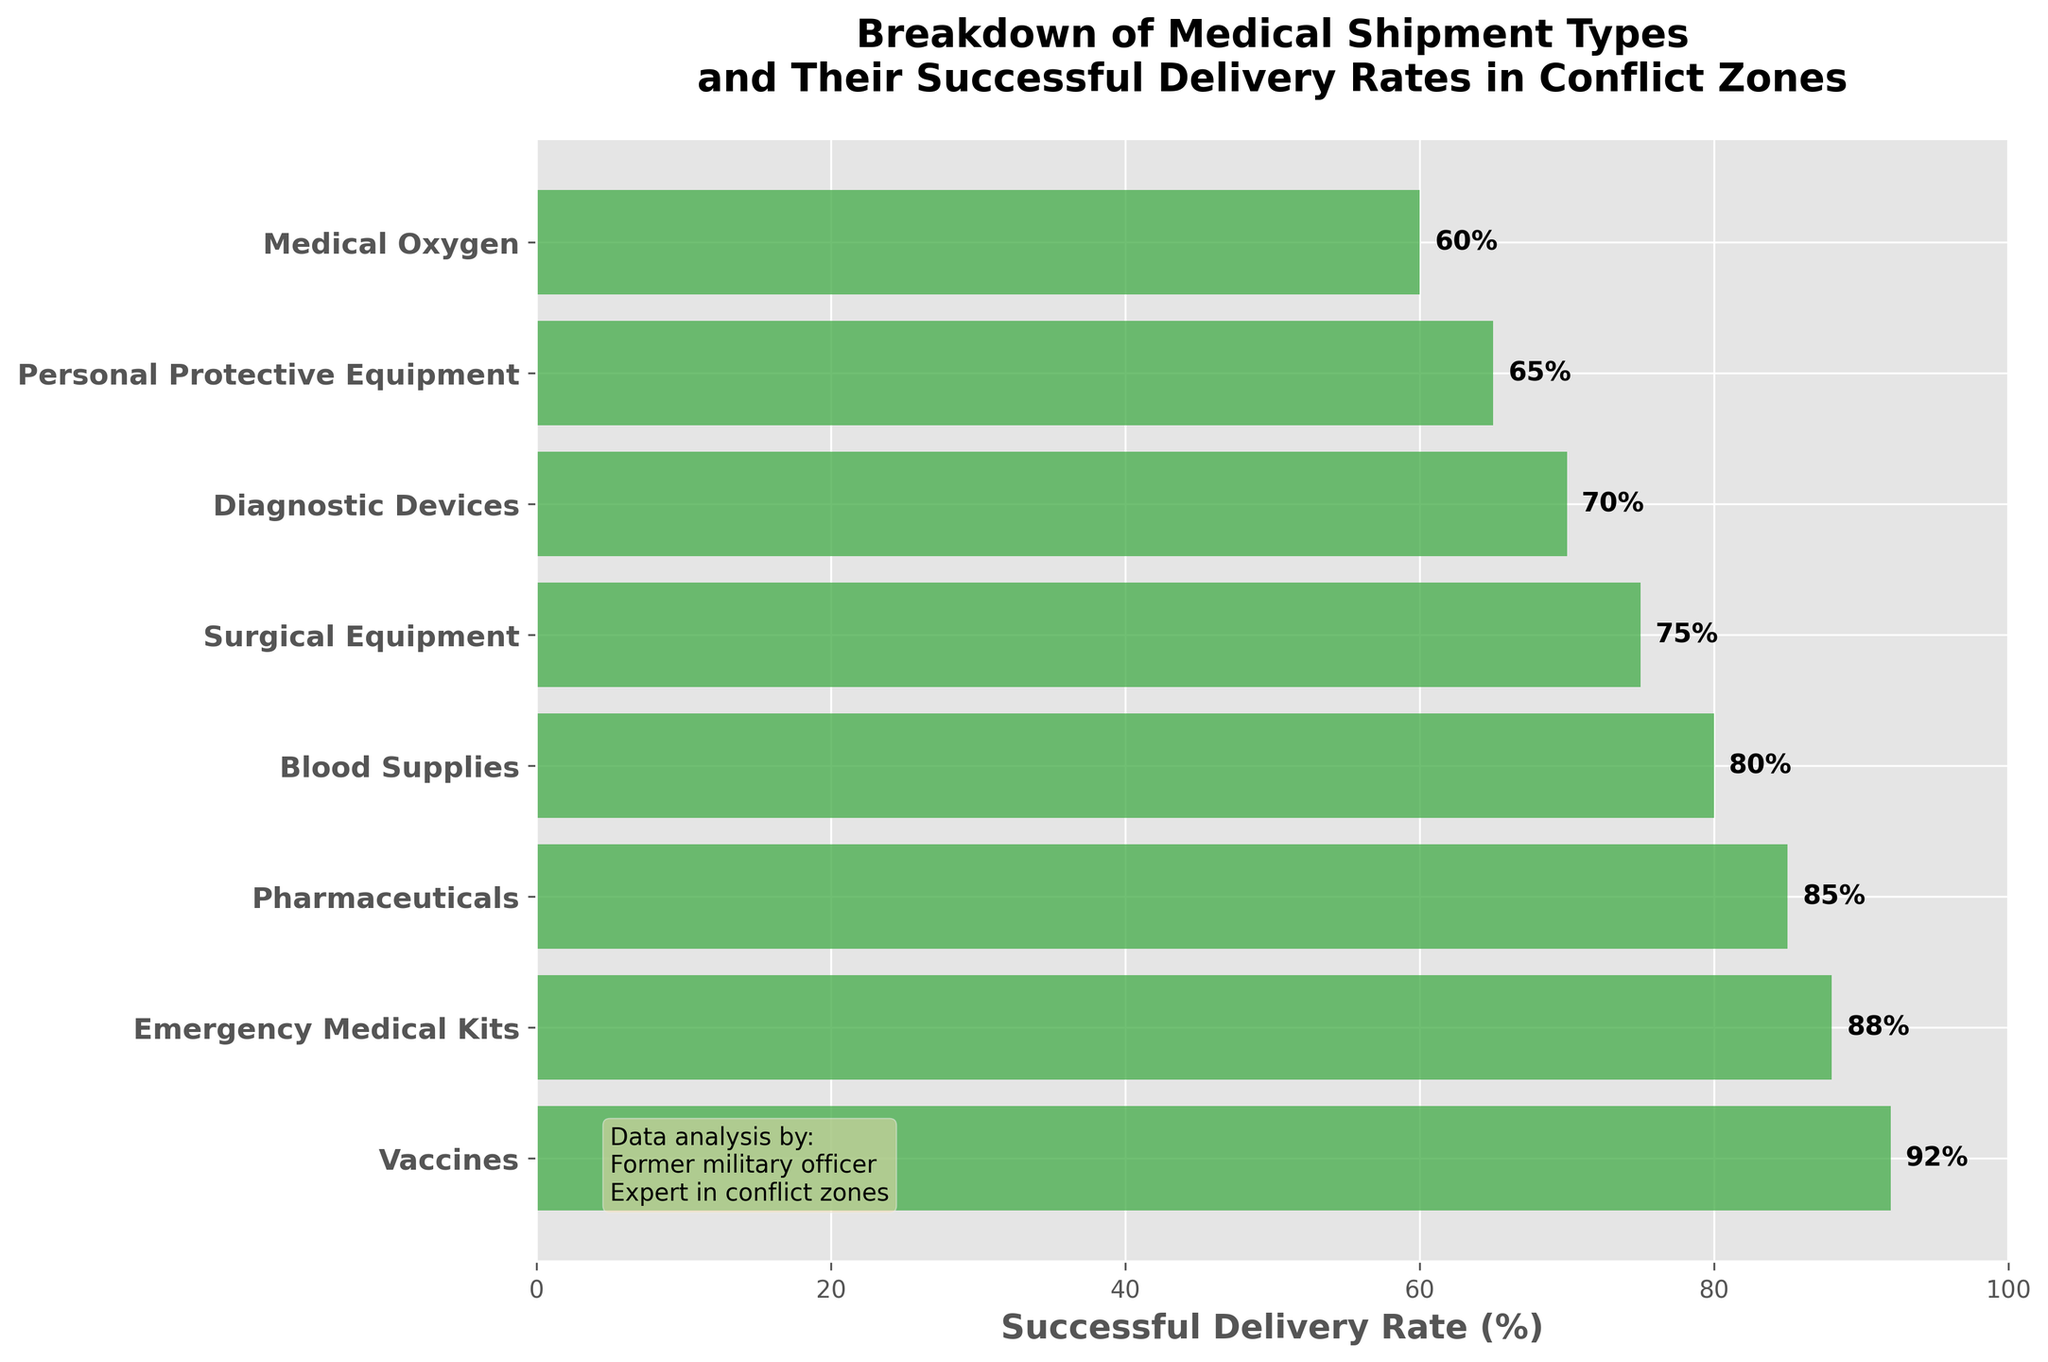What's the successful delivery rate for vaccines? The vaccines' successful delivery rate is displayed near the top of the funnel chart. The percentage is labeled directly on the bar.
Answer: 92% Which shipment type has the lowest successful delivery rate? By examining the funnel chart from top to bottom, Medical Oxygen is at the bottom and shows the lowest rate. The percentage label confirms this.
Answer: Medical Oxygen What's the difference in successful delivery rates between Pharmaceuticals and Blood Supplies? Locate the bars for Pharmaceuticals and Blood Supplies. Pharmaceuticals have a 85% rate and Blood Supplies have 80%. Subtract the Blood Supplies rate from the Pharmaceuticals rate: 85 - 80.
Answer: 5% What's the title of the figure? The title is prominently displayed at the top center of the figure. It helps viewers understand the main subject of the chart.
Answer: Breakdown of Medical Shipment Types and Their Successful Delivery Rates in Conflict Zones How many shipment types are displayed in the chart? The number of individual bars in the funnel chart corresponds to the number of shipment types. Count the distinct bars.
Answer: 8 Which shipment types have a successful delivery rate greater than 80%? Look at the bars that have a percentage label above the 80% mark.
Answer: Vaccines, Emergency Medical Kits, Pharmaceuticals What is the average successful delivery rate for Diagnostic Devices and Personal Protective Equipment? Find and add the successful delivery rates for Diagnostic Devices (70%) and Personal Protective Equipment (65%). Divide their sum by 2: (70 + 65) / 2.
Answer: 67.5% What's the successful delivery rate for the shipment type right above Medical Oxygen in the chart? Look at the shipment type immediately above Medical Oxygen in the funnel chart. The percentage label for Medical Oxygen is 60%, and for the one above (Personal Protective Equipment), it's 65%.
Answer: 65% How much more successful are Surgical Equipment deliveries compared to Medical Oxygen deliveries? Surgical Equipment has a 75% delivery rate, and Medical Oxygen has a 60% delivery rate. Subtract the latter from the former: 75 - 60.
Answer: 15% Is the successful delivery rate for Emergency Medical Kits higher than for Blood Supplies? Compare the percentage labels for Emergency Medical Kits (88%) and Blood Supplies (80%). Since 88% is higher than 80%, the answer is yes.
Answer: Yes 